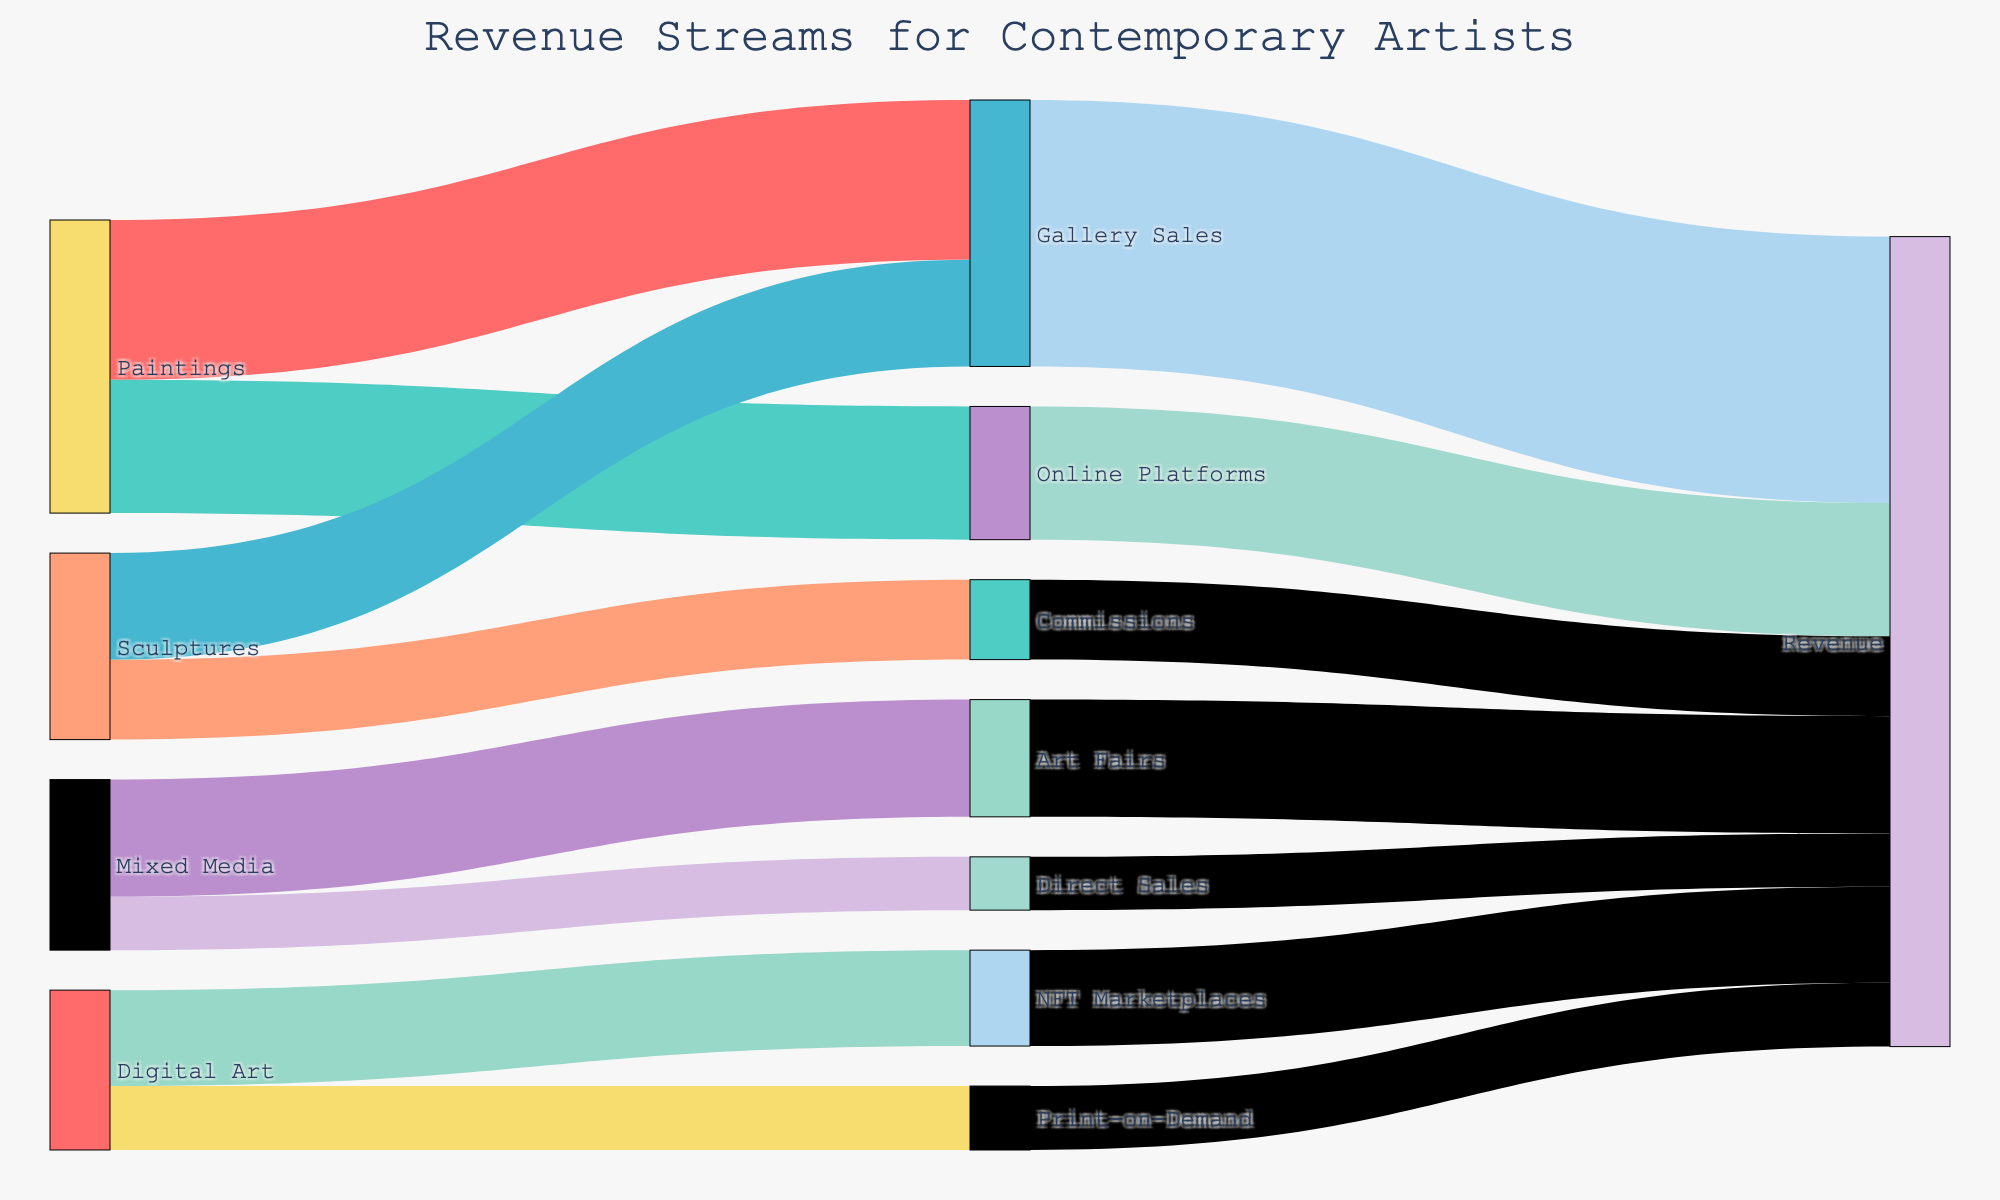what are the major revenue streams for digital art? By observing the links originating from 'Digital Art' in the Sankey diagram, we can see that the major revenue streams are 'NFT Marketplaces' and 'Print-on-Demand'.
Answer: NFT Marketplaces, Print-on-Demand which medium generates the most revenue through gallery sales? To find the medium that generates the most revenue through gallery sales, we look at the links going to 'Gallery Sales'. 'Paintings' contribute 30 units while 'Sculptures' contribute 20 units. Thus, Paintings generate the most revenue.
Answer: Paintings what is the total revenue generated by sculptures? By summing the values of the revenue streams for 'Sculptures', we see 20 units towards 'Gallery Sales' and 15 units from 'Commissions', adding up to a total of 35 units.
Answer: 35 units how does revenue from art fairs compare to direct sales for mixed media? Observing the links from 'Mixed Media', we see 'Art Fairs' have 22 units while 'Direct Sales' have 10 units. Therefore, revenue from art fairs is greater than direct sales.
Answer: Art Fairs have more revenue which revenue stream contributes the least to the final revenue? By examining all the revenue streams leading to 'Revenue', we observe that 'Direct Sales' contributes the least with 10 units.
Answer: Direct Sales are online platform sales more significant for paintings or digital art? Checking the links from 'Online Platforms' to different mediums, 'Paintings' contributes 25 units, but there is no contribution from 'Digital Art'. Hence, 'Paintings' is more significant.
Answer: Paintings what is the percentage contribution of gallery sales to the total revenue? 'Gallery Sales' contribute a total of 50 units. Summing the values of 'Revenue' from all streams (50 + 25 + 15 + 18 + 12 + 22 + 10 = 152), the percentage is (50/152) * 100 ≈ 32.89%.
Answer: 32.89% which medium has the most diverse revenue streams? By counting links originating from each medium, 'Paintings' has 2, 'Sculptures' has 2, 'Digital Art' has 2, and 'Mixed Media' has 2. All mediums have equally diverse streams with 2 revenue channels each.
Answer: All equally diverse which medium generates more revenue from non-digital channels, sculptures or paintings? Non-digital channels for 'Sculptures' are 'Gallery Sales' (20) and 'Commissions' (15), totaling 35 units. For 'Paintings', it's 'Gallery Sales' (30) and 'Online Platforms' (25). Although 'Online Platforms' could be considered digital, their total would be 55 units. Pure non-digital for paintings is lower than sculptures.
Answer: Sculptures 